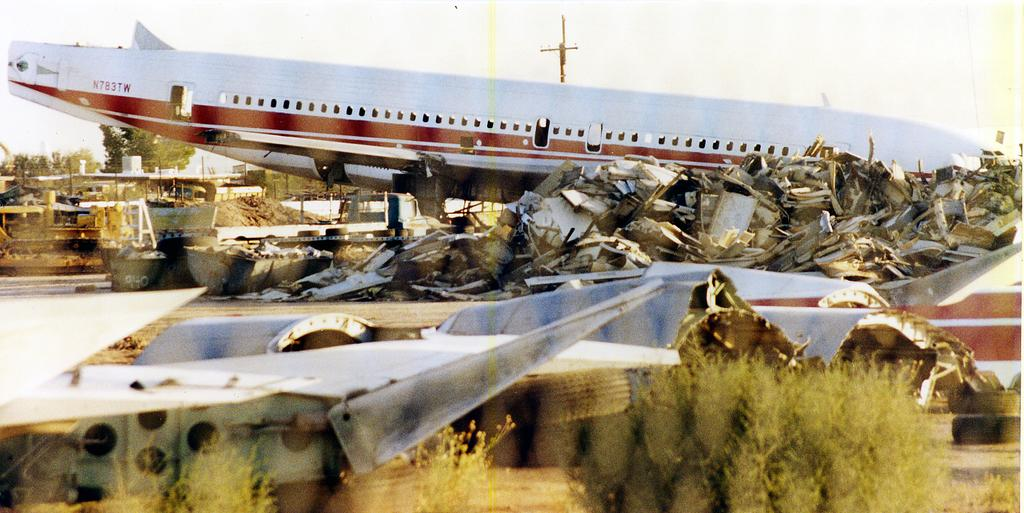What type of objects can be seen in the picture? There are scraps of aircrafts in the picture. What can be seen in the background of the picture? Trees and the sky are visible in the background of the picture. How does the engine of the aircraft handle the rainstorm in the image? There is no engine or rainstorm present in the image; it features scraps of aircrafts and a background with trees and the sky. 